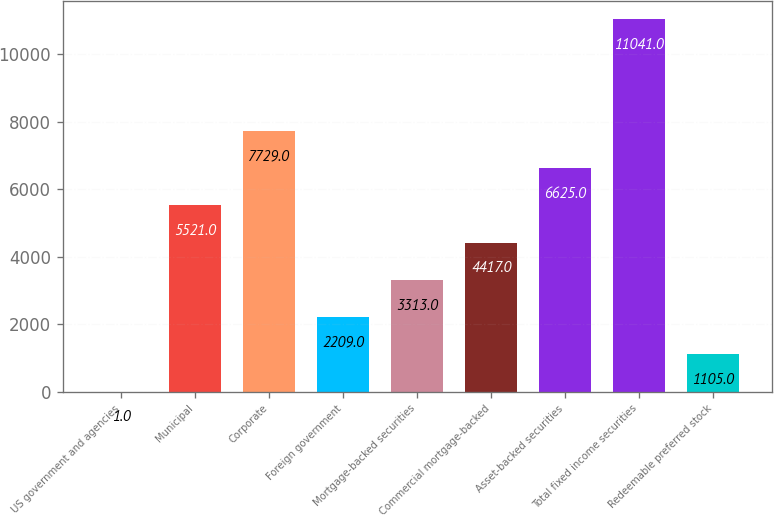Convert chart to OTSL. <chart><loc_0><loc_0><loc_500><loc_500><bar_chart><fcel>US government and agencies<fcel>Municipal<fcel>Corporate<fcel>Foreign government<fcel>Mortgage-backed securities<fcel>Commercial mortgage-backed<fcel>Asset-backed securities<fcel>Total fixed income securities<fcel>Redeemable preferred stock<nl><fcel>1<fcel>5521<fcel>7729<fcel>2209<fcel>3313<fcel>4417<fcel>6625<fcel>11041<fcel>1105<nl></chart> 